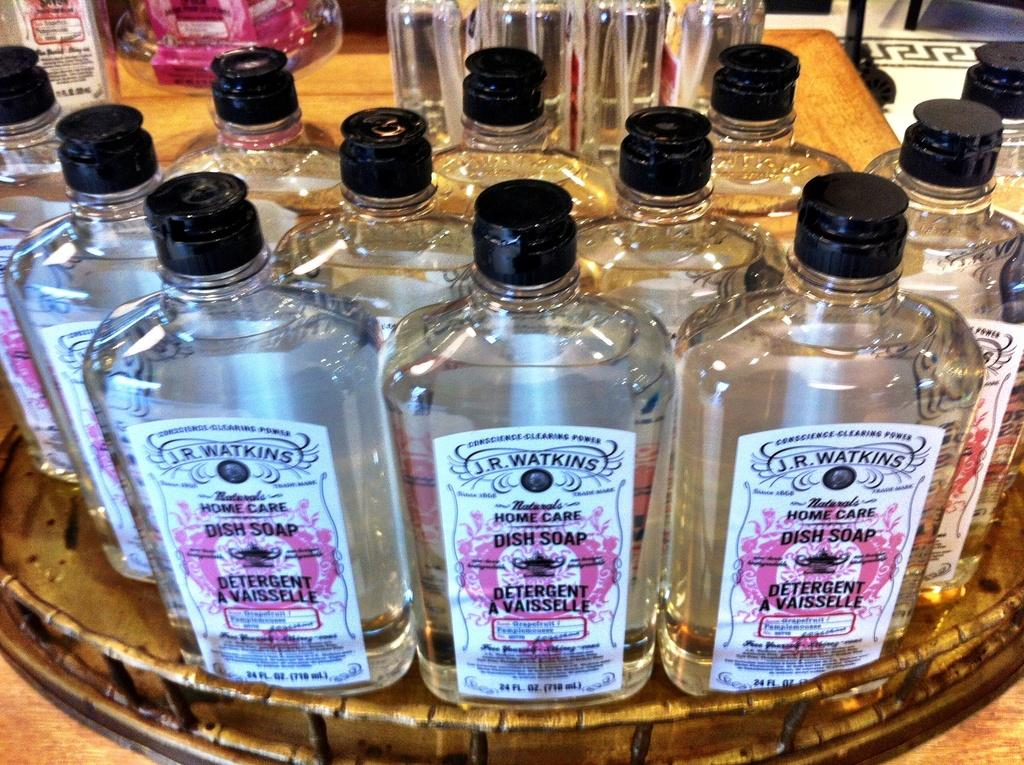<image>
Give a short and clear explanation of the subsequent image. A close up image of a display of J.R. Watkins dish soap. 